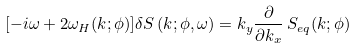<formula> <loc_0><loc_0><loc_500><loc_500>[ - i \omega + 2 \omega _ { H } ( k ; \phi ) ] \delta S \, ( { k } ; \phi , \omega ) = k _ { y } \frac { \partial } { \partial k _ { x } } \, S _ { e q } ( k ; \phi )</formula> 